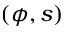Convert formula to latex. <formula><loc_0><loc_0><loc_500><loc_500>( \phi , s )</formula> 